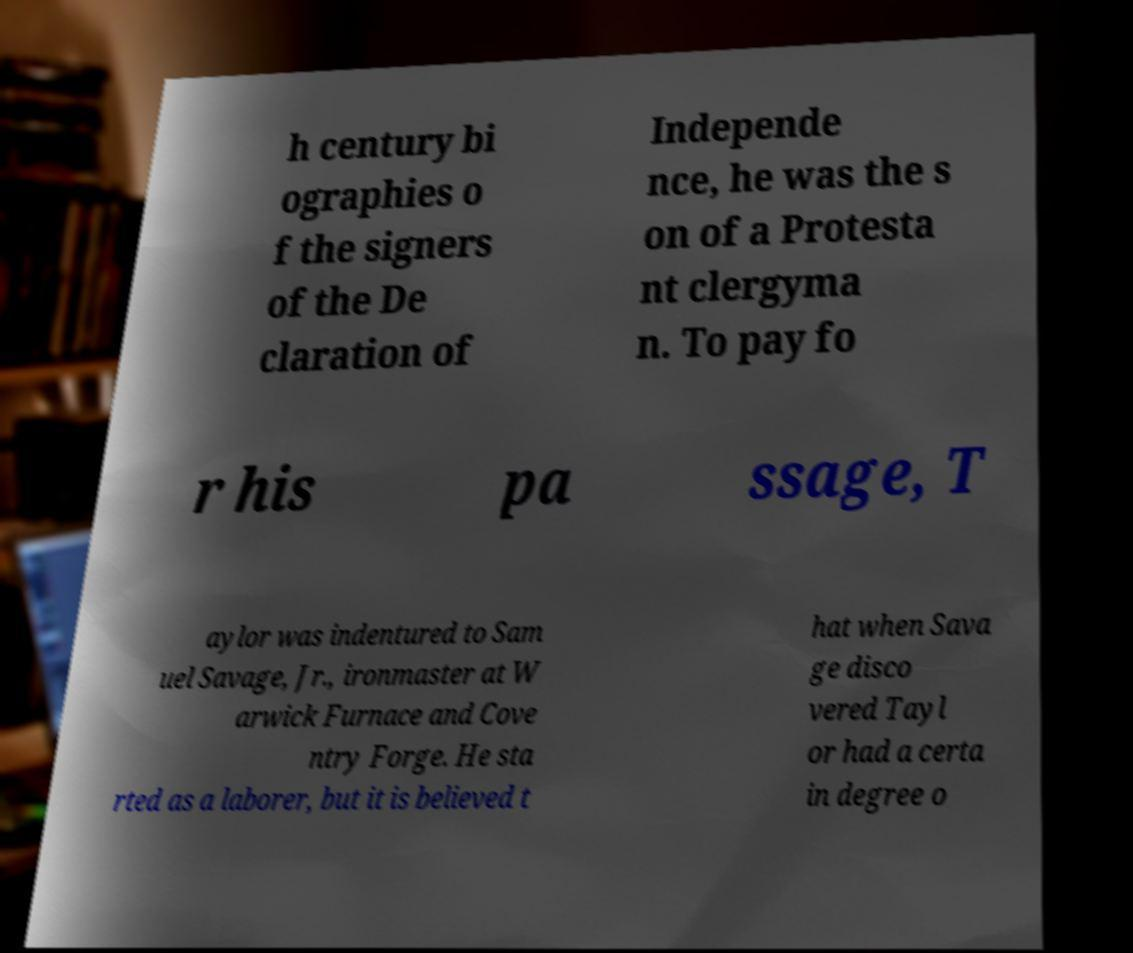Can you read and provide the text displayed in the image?This photo seems to have some interesting text. Can you extract and type it out for me? h century bi ographies o f the signers of the De claration of Independe nce, he was the s on of a Protesta nt clergyma n. To pay fo r his pa ssage, T aylor was indentured to Sam uel Savage, Jr., ironmaster at W arwick Furnace and Cove ntry Forge. He sta rted as a laborer, but it is believed t hat when Sava ge disco vered Tayl or had a certa in degree o 